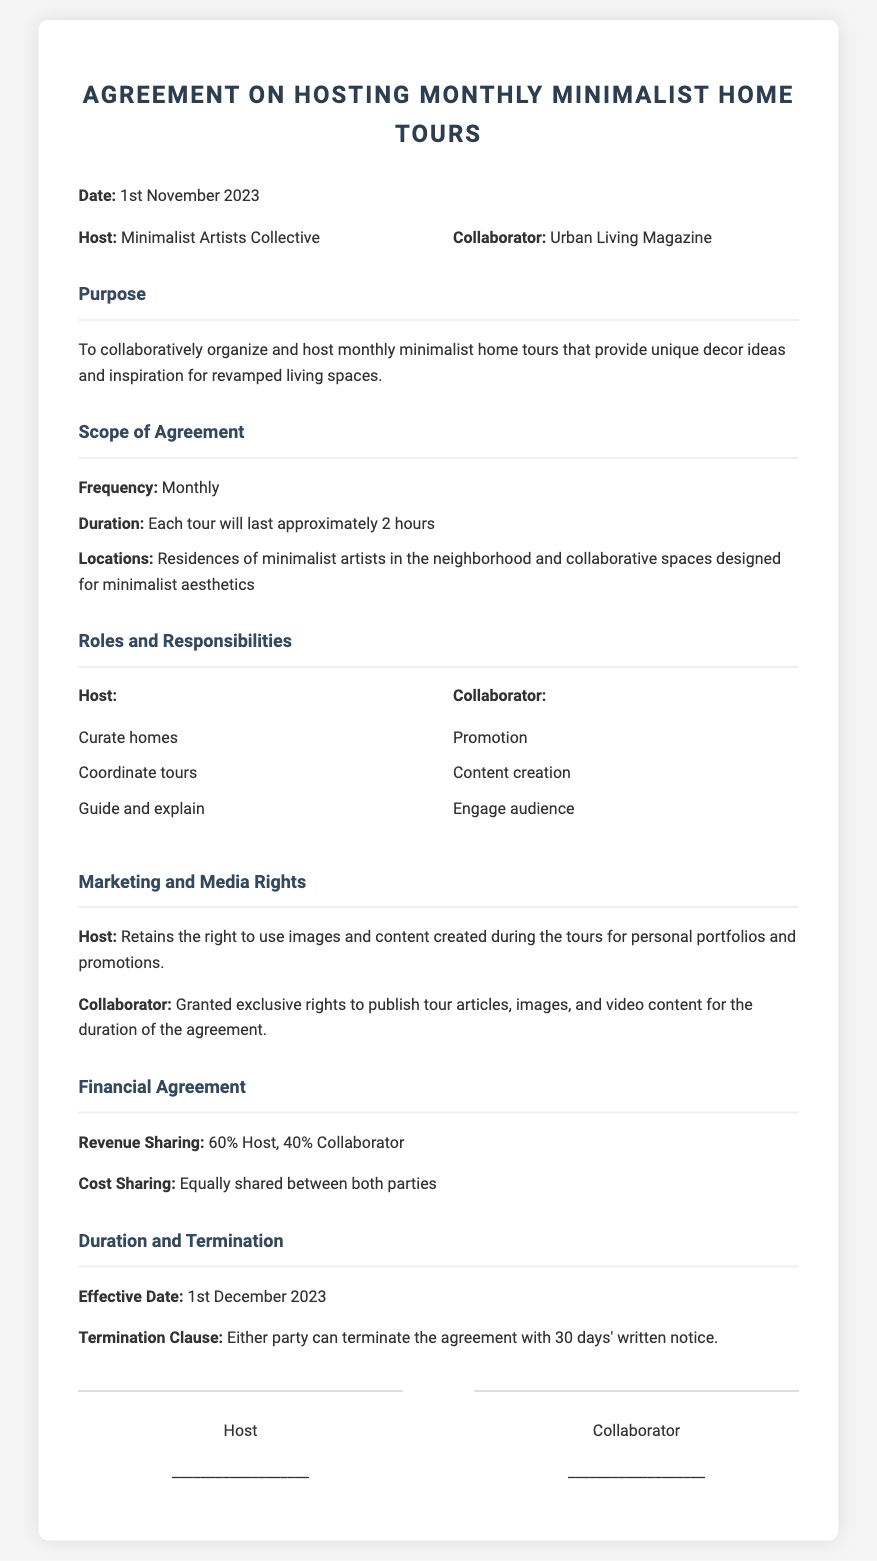What is the effective date of the agreement? The effective date is explicitly stated in the document, which is mentioned under the "Duration and Termination" section.
Answer: 1st December 2023 Who is the collaborator in this agreement? The collaborator is identified clearly at the beginning of the document in the "parties" section.
Answer: Urban Living Magazine What is the duration of each tour? The duration of each tour is mentioned under the "Scope of Agreement" section, where it specifies the length of time for the tours.
Answer: Approximately 2 hours What percentage of revenue does the host receive? The revenue sharing percentage for the host is stated in the "Financial Agreement" section.
Answer: 60% What does the host need to do according to their responsibilities? The responsibilities of the host are outlined, specifically under the "Roles and Responsibilities" section, detailing tasks expected of them.
Answer: Curate homes How many days notice is required for termination? The notice period for termination is specified under the "Duration and Termination" section, indicating how much prior notice is needed.
Answer: 30 days What is the main purpose of this agreement? The purpose of the agreement is clearly articulated at the beginning of the document right after the title.
Answer: Organize and host monthly minimalist home tours What type of content rights does the collaborator have? The rights of the collaborator related to content are highlighted in the "Marketing and Media Rights" section concerning publications during the agreement.
Answer: Exclusive rights to publish tour articles What locations will the tours be held in? The locations for the tours are specified in the "Scope of Agreement" section, providing details about where the tours will take place.
Answer: Residences of minimalist artists and collaborative spaces 